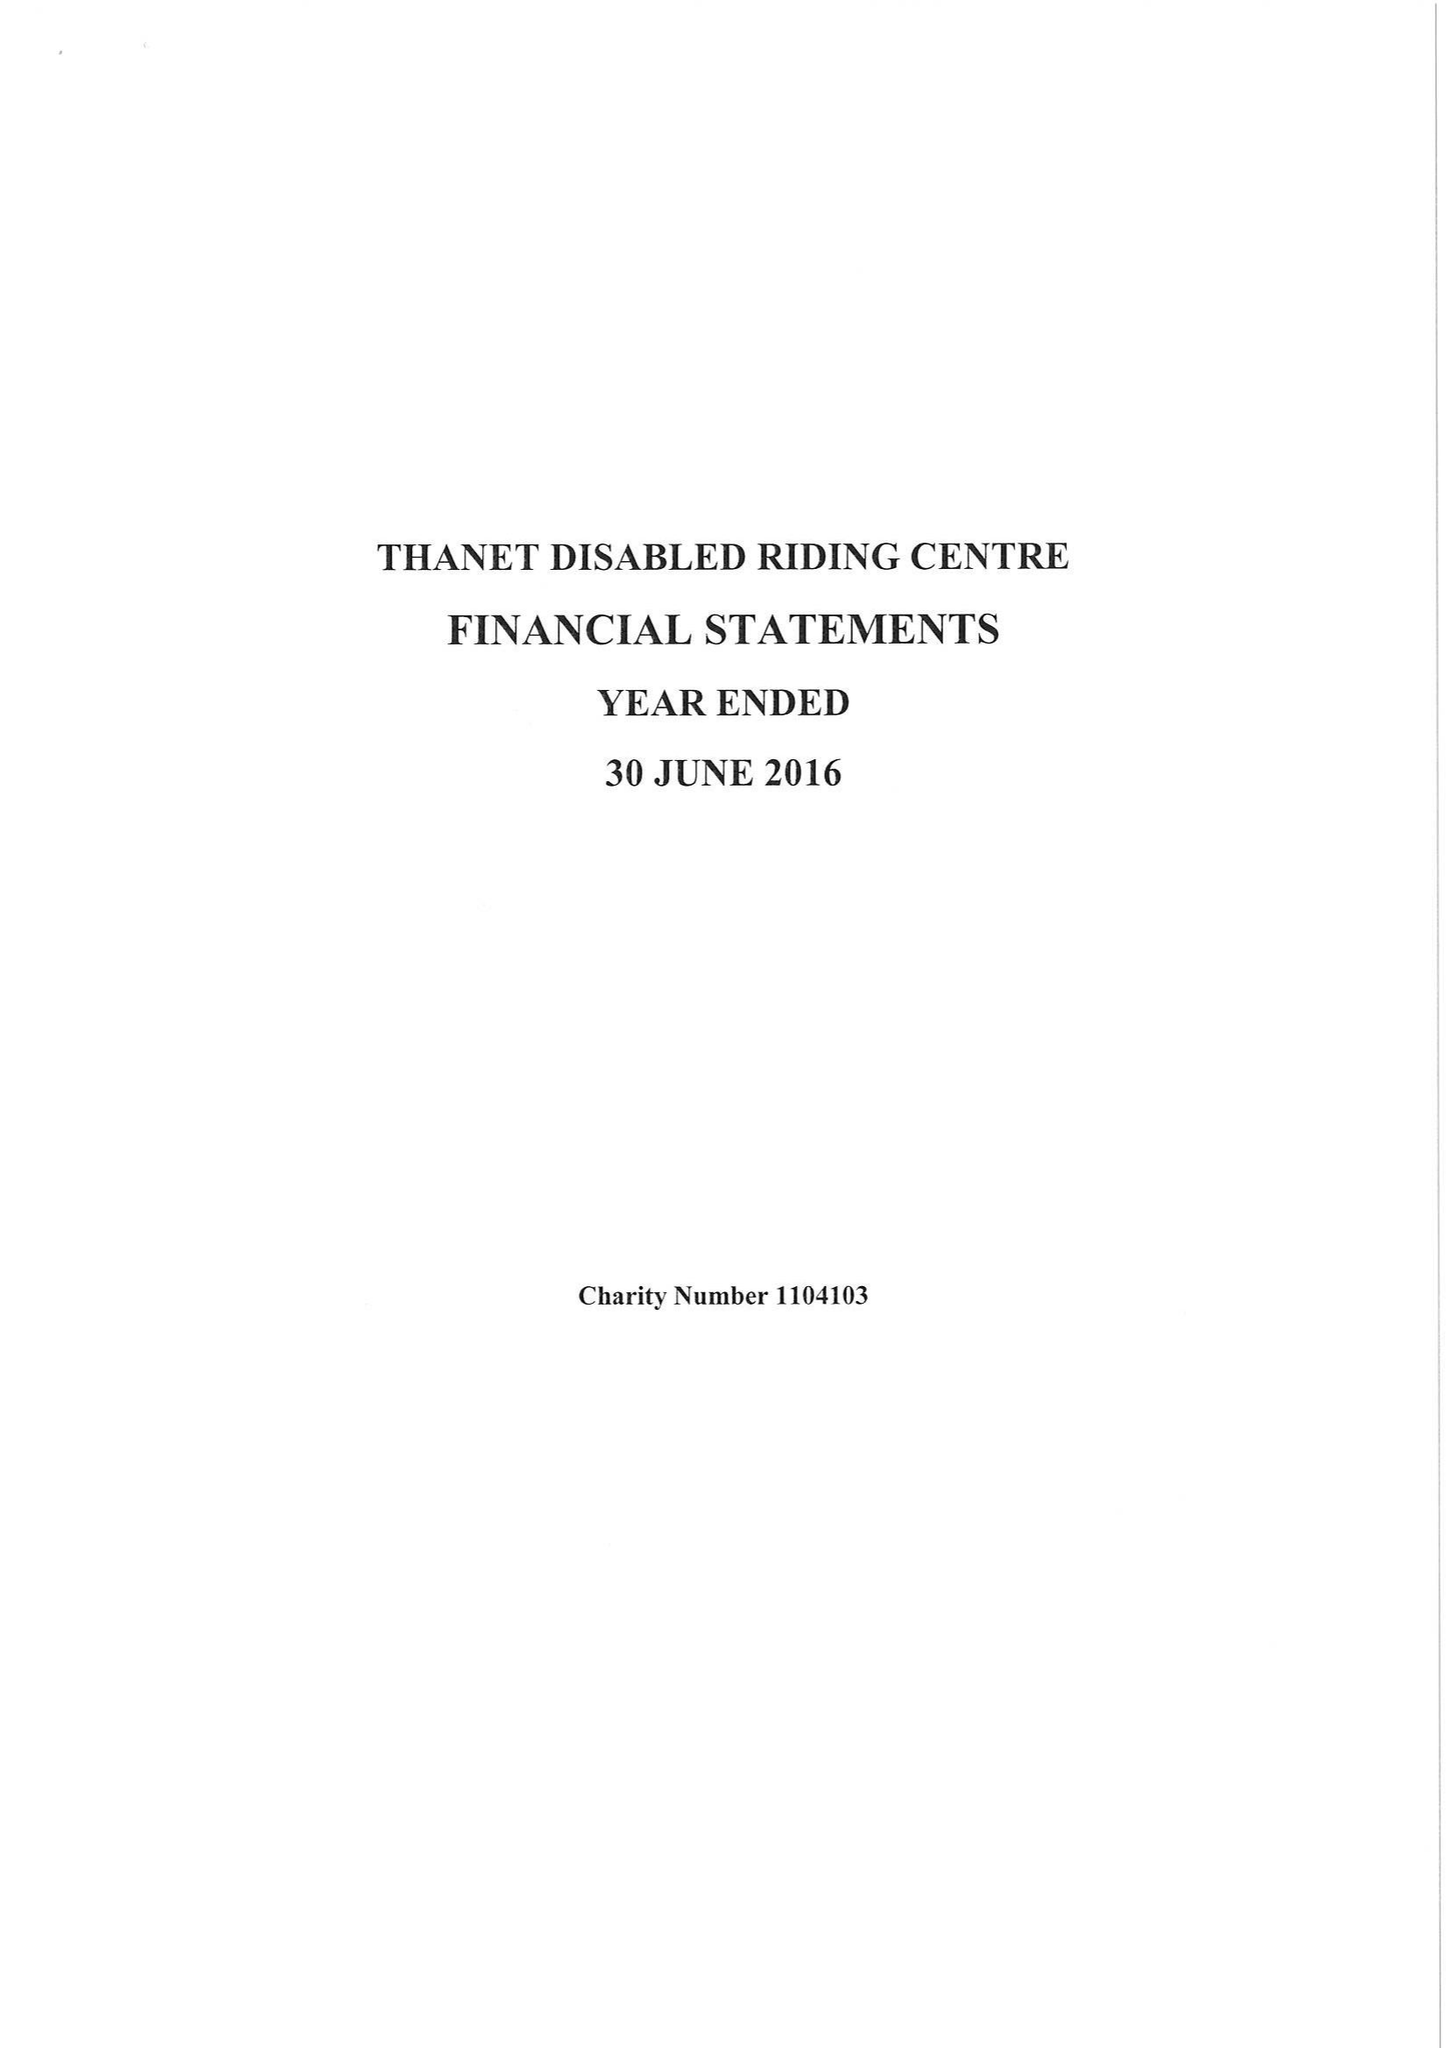What is the value for the charity_number?
Answer the question using a single word or phrase. 1104103 